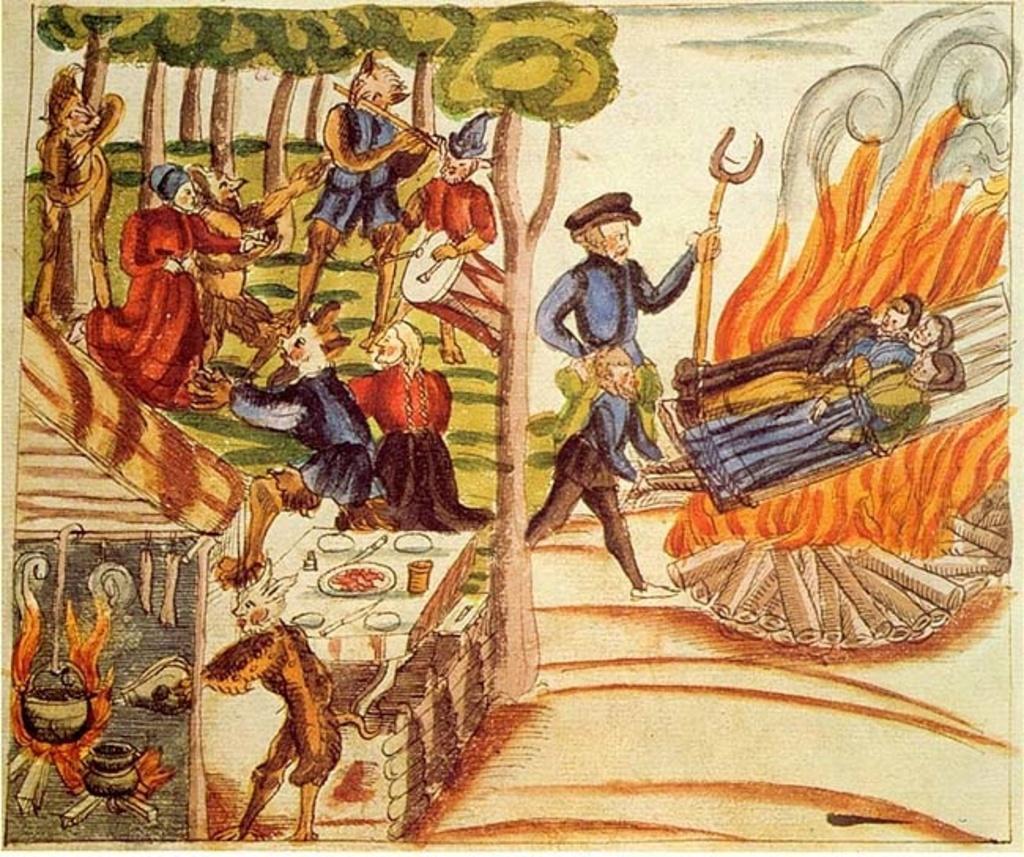In one or two sentences, can you explain what this image depicts? This image is a painting. In this image we can see people and there is a fire. We can see logs and there are trees. There are animals. 